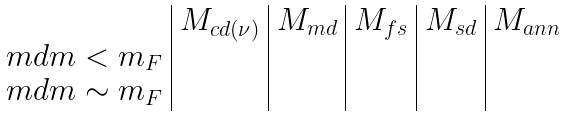<formula> <loc_0><loc_0><loc_500><loc_500>\begin{array} { l | l | l | l | l | l } & M _ { c d ( \nu ) } & M _ { m d } & M _ { f s } & M _ { s d } & M _ { a n n } \\ \ m d m < m _ { F } & & & & & \\ \ m d m \sim m _ { F } & & & & & \\ \end{array}</formula> 